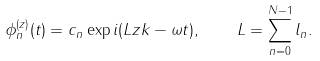Convert formula to latex. <formula><loc_0><loc_0><loc_500><loc_500>\phi _ { n } ^ { ( z ) } ( t ) = c _ { n } \exp i ( L z k - \omega t ) , \quad L = \sum _ { n = 0 } ^ { N - 1 } l _ { n } .</formula> 